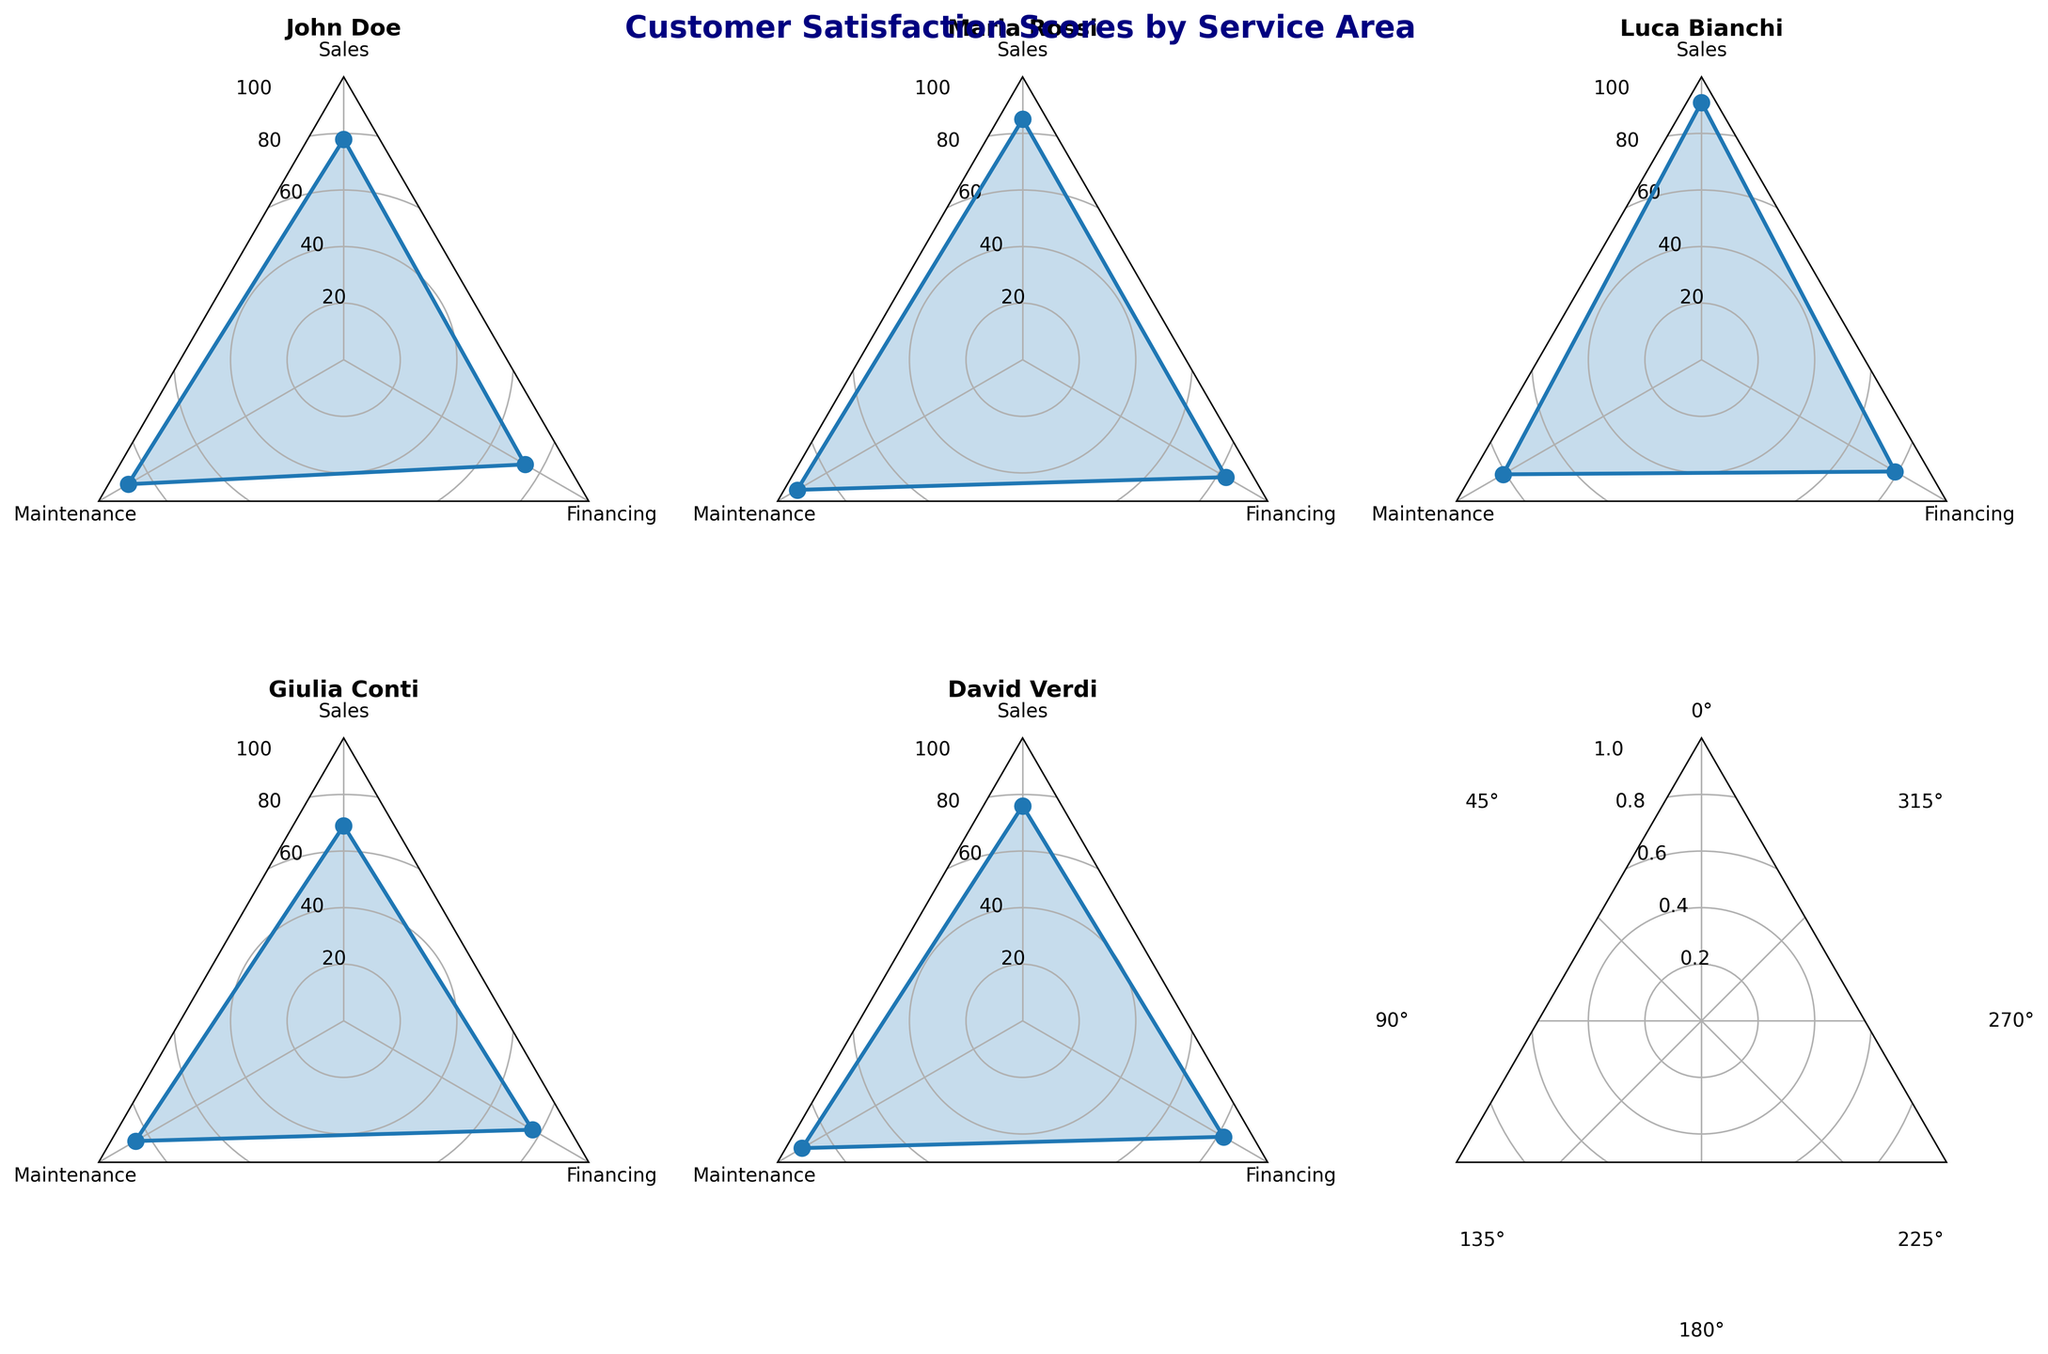What is the title of the figure? The title is usually found at the top of the figure, above the subplots. It gives an overview of what the data represents.
Answer: Customer Satisfaction Scores by Service Area How many customers are represented in the figure? Each subplot corresponds to one customer. Observe the number of subplots to find this information. There are five subplots, so there are five customers.
Answer: 5 Which service area received the highest score from John Doe? Look at John Doe's subplot and identify the highest point on his radar chart. The highest score for John Doe is on the Maintenance axis.
Answer: Maintenance Which customer gave the lowest score in the Financing service area? Check the data points on the Financing axis for each customer's subplot and identify the one with the lowest value. Luca Bianchi has the lowest Financing score, which is 79.
Answer: Luca Bianchi What is the average score Luca Bianchi gave across all service areas? Add Luca Bianchi's scores (Sales: 91, Maintenance: 81, Financing: 79) and divide by the number of service areas (3). (91 + 81 + 79) / 3 = 83.67
Answer: 83.67 Among all customers, who gave the highest score in Maintenance? Observe the Maintenance axis across all subplots and find the highest score. Maria Rossi gave the highest Maintenance score, which is 92.
Answer: Maria Rossi Which customer has the most consistent scores across all service areas? Consistent scores would have less variation between them. Check the radar charts and see whose lines are more evenly spread. David Verdi's scores are the most consistent (Sales: 76, Maintenance: 90, Financing: 82).
Answer: David Verdi How do Maria Rossi's scores compare in Sales and Maintenance? Look at Maria Rossi's subplot and compare the values on the Sales and Maintenance axes. Her scores are 85 in Sales and 92 in Maintenance. Maintenance score is higher.
Answer: Her Maintenance score is higher What is the overall trend in Financing scores among all customers? Examine the Financing axis for each subplot and observe the general behavior of the scores. Most scores are in the range between 74 and 83, indicating moderate satisfaction in Financing.
Answer: Moderate satisfaction Which service area shows the most variation in scores among all customers? Compare the spread of scores on each axis for all subplots. The Sales axis shows the most variation, ranging from 69 to 91.
Answer: Sales 